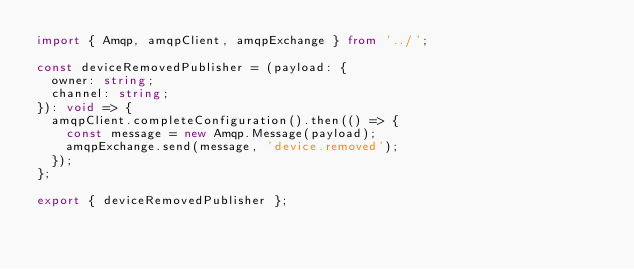Convert code to text. <code><loc_0><loc_0><loc_500><loc_500><_TypeScript_>import { Amqp, amqpClient, amqpExchange } from '../';

const deviceRemovedPublisher = (payload: {
  owner: string;
  channel: string;
}): void => {
  amqpClient.completeConfiguration().then(() => {
    const message = new Amqp.Message(payload);
    amqpExchange.send(message, 'device.removed');
  });
};

export { deviceRemovedPublisher };
</code> 